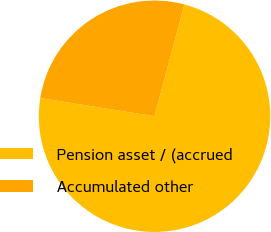<chart> <loc_0><loc_0><loc_500><loc_500><pie_chart><fcel>Pension asset / (accrued<fcel>Accumulated other<nl><fcel>73.35%<fcel>26.65%<nl></chart> 